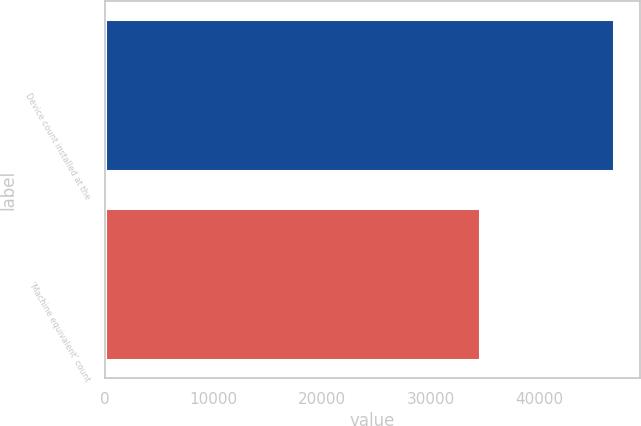Convert chart to OTSL. <chart><loc_0><loc_0><loc_500><loc_500><bar_chart><fcel>Device count installed at the<fcel>'Machine equivalent' count<nl><fcel>46855<fcel>34529<nl></chart> 